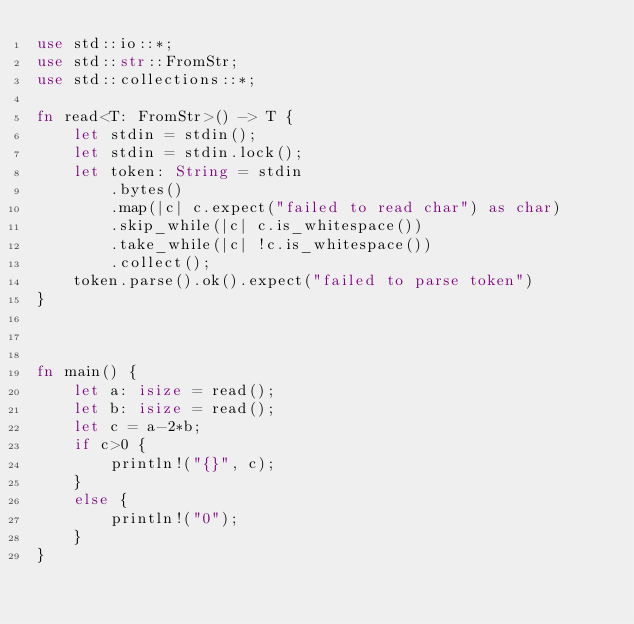Convert code to text. <code><loc_0><loc_0><loc_500><loc_500><_Rust_>use std::io::*;
use std::str::FromStr;
use std::collections::*;

fn read<T: FromStr>() -> T {
    let stdin = stdin();
    let stdin = stdin.lock();
    let token: String = stdin
        .bytes()
        .map(|c| c.expect("failed to read char") as char) 
        .skip_while(|c| c.is_whitespace())
        .take_while(|c| !c.is_whitespace())
        .collect();
    token.parse().ok().expect("failed to parse token")
}



fn main() {
    let a: isize = read();
    let b: isize = read();
    let c = a-2*b;
    if c>0 {
        println!("{}", c);
    }
    else {
        println!("0");
    }
}</code> 